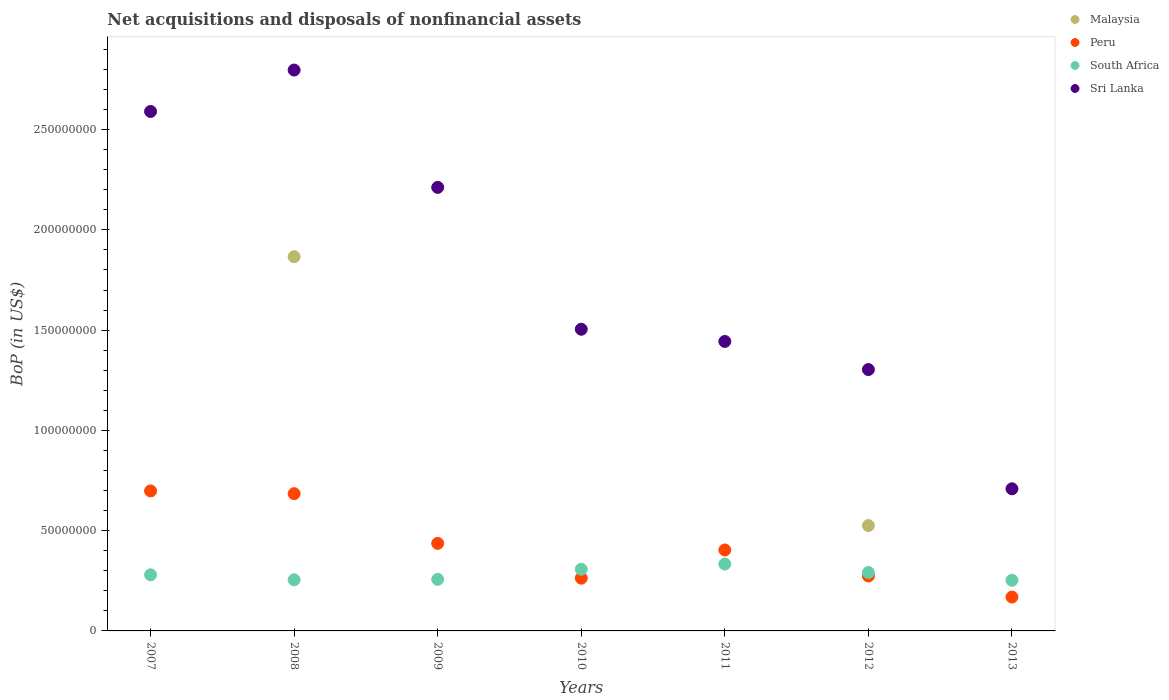How many different coloured dotlines are there?
Your response must be concise. 4. What is the Balance of Payments in South Africa in 2013?
Ensure brevity in your answer.  2.52e+07. Across all years, what is the maximum Balance of Payments in South Africa?
Your response must be concise. 3.33e+07. Across all years, what is the minimum Balance of Payments in South Africa?
Provide a short and direct response. 2.52e+07. What is the total Balance of Payments in Peru in the graph?
Give a very brief answer. 2.93e+08. What is the difference between the Balance of Payments in South Africa in 2009 and that in 2011?
Your response must be concise. -7.60e+06. What is the difference between the Balance of Payments in Malaysia in 2013 and the Balance of Payments in Peru in 2012?
Your response must be concise. -2.74e+07. What is the average Balance of Payments in Peru per year?
Offer a terse response. 4.18e+07. In the year 2013, what is the difference between the Balance of Payments in South Africa and Balance of Payments in Sri Lanka?
Make the answer very short. -4.56e+07. In how many years, is the Balance of Payments in South Africa greater than 170000000 US$?
Ensure brevity in your answer.  0. What is the ratio of the Balance of Payments in Peru in 2011 to that in 2013?
Give a very brief answer. 2.39. Is the difference between the Balance of Payments in South Africa in 2008 and 2013 greater than the difference between the Balance of Payments in Sri Lanka in 2008 and 2013?
Offer a very short reply. No. What is the difference between the highest and the second highest Balance of Payments in Peru?
Your answer should be compact. 1.36e+06. What is the difference between the highest and the lowest Balance of Payments in Sri Lanka?
Provide a short and direct response. 2.09e+08. Is the sum of the Balance of Payments in South Africa in 2010 and 2012 greater than the maximum Balance of Payments in Peru across all years?
Offer a very short reply. No. Is it the case that in every year, the sum of the Balance of Payments in South Africa and Balance of Payments in Peru  is greater than the sum of Balance of Payments in Malaysia and Balance of Payments in Sri Lanka?
Give a very brief answer. No. Is it the case that in every year, the sum of the Balance of Payments in South Africa and Balance of Payments in Sri Lanka  is greater than the Balance of Payments in Malaysia?
Your answer should be compact. Yes. Does the Balance of Payments in Malaysia monotonically increase over the years?
Ensure brevity in your answer.  No. Is the Balance of Payments in Peru strictly greater than the Balance of Payments in Sri Lanka over the years?
Provide a short and direct response. No. How many dotlines are there?
Provide a short and direct response. 4. What is the difference between two consecutive major ticks on the Y-axis?
Offer a very short reply. 5.00e+07. Are the values on the major ticks of Y-axis written in scientific E-notation?
Ensure brevity in your answer.  No. Does the graph contain any zero values?
Your response must be concise. Yes. How many legend labels are there?
Your response must be concise. 4. How are the legend labels stacked?
Your answer should be very brief. Vertical. What is the title of the graph?
Give a very brief answer. Net acquisitions and disposals of nonfinancial assets. Does "Caribbean small states" appear as one of the legend labels in the graph?
Ensure brevity in your answer.  No. What is the label or title of the Y-axis?
Your response must be concise. BoP (in US$). What is the BoP (in US$) of Peru in 2007?
Ensure brevity in your answer.  6.98e+07. What is the BoP (in US$) in South Africa in 2007?
Keep it short and to the point. 2.80e+07. What is the BoP (in US$) in Sri Lanka in 2007?
Provide a short and direct response. 2.59e+08. What is the BoP (in US$) in Malaysia in 2008?
Give a very brief answer. 1.87e+08. What is the BoP (in US$) in Peru in 2008?
Offer a very short reply. 6.84e+07. What is the BoP (in US$) of South Africa in 2008?
Offer a very short reply. 2.55e+07. What is the BoP (in US$) in Sri Lanka in 2008?
Your answer should be compact. 2.80e+08. What is the BoP (in US$) in Peru in 2009?
Your answer should be very brief. 4.37e+07. What is the BoP (in US$) of South Africa in 2009?
Offer a terse response. 2.57e+07. What is the BoP (in US$) of Sri Lanka in 2009?
Keep it short and to the point. 2.21e+08. What is the BoP (in US$) of Peru in 2010?
Provide a succinct answer. 2.63e+07. What is the BoP (in US$) of South Africa in 2010?
Ensure brevity in your answer.  3.08e+07. What is the BoP (in US$) in Sri Lanka in 2010?
Provide a succinct answer. 1.50e+08. What is the BoP (in US$) in Malaysia in 2011?
Your answer should be compact. 0. What is the BoP (in US$) in Peru in 2011?
Offer a terse response. 4.04e+07. What is the BoP (in US$) in South Africa in 2011?
Make the answer very short. 3.33e+07. What is the BoP (in US$) of Sri Lanka in 2011?
Ensure brevity in your answer.  1.44e+08. What is the BoP (in US$) in Malaysia in 2012?
Give a very brief answer. 5.25e+07. What is the BoP (in US$) of Peru in 2012?
Provide a short and direct response. 2.74e+07. What is the BoP (in US$) of South Africa in 2012?
Ensure brevity in your answer.  2.91e+07. What is the BoP (in US$) of Sri Lanka in 2012?
Offer a very short reply. 1.30e+08. What is the BoP (in US$) in Malaysia in 2013?
Provide a short and direct response. 0. What is the BoP (in US$) of Peru in 2013?
Keep it short and to the point. 1.69e+07. What is the BoP (in US$) in South Africa in 2013?
Your answer should be compact. 2.52e+07. What is the BoP (in US$) of Sri Lanka in 2013?
Make the answer very short. 7.09e+07. Across all years, what is the maximum BoP (in US$) in Malaysia?
Give a very brief answer. 1.87e+08. Across all years, what is the maximum BoP (in US$) of Peru?
Provide a succinct answer. 6.98e+07. Across all years, what is the maximum BoP (in US$) in South Africa?
Your answer should be very brief. 3.33e+07. Across all years, what is the maximum BoP (in US$) of Sri Lanka?
Give a very brief answer. 2.80e+08. Across all years, what is the minimum BoP (in US$) of Peru?
Ensure brevity in your answer.  1.69e+07. Across all years, what is the minimum BoP (in US$) of South Africa?
Keep it short and to the point. 2.52e+07. Across all years, what is the minimum BoP (in US$) in Sri Lanka?
Offer a very short reply. 7.09e+07. What is the total BoP (in US$) of Malaysia in the graph?
Offer a terse response. 2.39e+08. What is the total BoP (in US$) of Peru in the graph?
Ensure brevity in your answer.  2.93e+08. What is the total BoP (in US$) in South Africa in the graph?
Offer a terse response. 1.98e+08. What is the total BoP (in US$) in Sri Lanka in the graph?
Your answer should be very brief. 1.26e+09. What is the difference between the BoP (in US$) of Peru in 2007 and that in 2008?
Provide a succinct answer. 1.36e+06. What is the difference between the BoP (in US$) of South Africa in 2007 and that in 2008?
Make the answer very short. 2.48e+06. What is the difference between the BoP (in US$) of Sri Lanka in 2007 and that in 2008?
Provide a succinct answer. -2.06e+07. What is the difference between the BoP (in US$) of Peru in 2007 and that in 2009?
Provide a succinct answer. 2.61e+07. What is the difference between the BoP (in US$) in South Africa in 2007 and that in 2009?
Keep it short and to the point. 2.25e+06. What is the difference between the BoP (in US$) in Sri Lanka in 2007 and that in 2009?
Offer a terse response. 3.78e+07. What is the difference between the BoP (in US$) in Peru in 2007 and that in 2010?
Offer a very short reply. 4.35e+07. What is the difference between the BoP (in US$) of South Africa in 2007 and that in 2010?
Provide a short and direct response. -2.79e+06. What is the difference between the BoP (in US$) in Sri Lanka in 2007 and that in 2010?
Your response must be concise. 1.09e+08. What is the difference between the BoP (in US$) of Peru in 2007 and that in 2011?
Make the answer very short. 2.94e+07. What is the difference between the BoP (in US$) of South Africa in 2007 and that in 2011?
Provide a short and direct response. -5.35e+06. What is the difference between the BoP (in US$) of Sri Lanka in 2007 and that in 2011?
Provide a succinct answer. 1.15e+08. What is the difference between the BoP (in US$) in Peru in 2007 and that in 2012?
Give a very brief answer. 4.24e+07. What is the difference between the BoP (in US$) of South Africa in 2007 and that in 2012?
Your answer should be compact. -1.16e+06. What is the difference between the BoP (in US$) in Sri Lanka in 2007 and that in 2012?
Your answer should be compact. 1.29e+08. What is the difference between the BoP (in US$) in Peru in 2007 and that in 2013?
Give a very brief answer. 5.29e+07. What is the difference between the BoP (in US$) in South Africa in 2007 and that in 2013?
Ensure brevity in your answer.  2.74e+06. What is the difference between the BoP (in US$) in Sri Lanka in 2007 and that in 2013?
Provide a succinct answer. 1.88e+08. What is the difference between the BoP (in US$) in Peru in 2008 and that in 2009?
Ensure brevity in your answer.  2.48e+07. What is the difference between the BoP (in US$) in South Africa in 2008 and that in 2009?
Provide a short and direct response. -2.34e+05. What is the difference between the BoP (in US$) of Sri Lanka in 2008 and that in 2009?
Ensure brevity in your answer.  5.85e+07. What is the difference between the BoP (in US$) in Peru in 2008 and that in 2010?
Provide a succinct answer. 4.21e+07. What is the difference between the BoP (in US$) of South Africa in 2008 and that in 2010?
Offer a very short reply. -5.27e+06. What is the difference between the BoP (in US$) of Sri Lanka in 2008 and that in 2010?
Make the answer very short. 1.29e+08. What is the difference between the BoP (in US$) in Peru in 2008 and that in 2011?
Your answer should be very brief. 2.81e+07. What is the difference between the BoP (in US$) of South Africa in 2008 and that in 2011?
Your response must be concise. -7.83e+06. What is the difference between the BoP (in US$) in Sri Lanka in 2008 and that in 2011?
Keep it short and to the point. 1.35e+08. What is the difference between the BoP (in US$) of Malaysia in 2008 and that in 2012?
Make the answer very short. 1.34e+08. What is the difference between the BoP (in US$) in Peru in 2008 and that in 2012?
Make the answer very short. 4.10e+07. What is the difference between the BoP (in US$) of South Africa in 2008 and that in 2012?
Make the answer very short. -3.64e+06. What is the difference between the BoP (in US$) of Sri Lanka in 2008 and that in 2012?
Your answer should be very brief. 1.49e+08. What is the difference between the BoP (in US$) in Peru in 2008 and that in 2013?
Offer a terse response. 5.16e+07. What is the difference between the BoP (in US$) of South Africa in 2008 and that in 2013?
Provide a succinct answer. 2.55e+05. What is the difference between the BoP (in US$) in Sri Lanka in 2008 and that in 2013?
Make the answer very short. 2.09e+08. What is the difference between the BoP (in US$) of Peru in 2009 and that in 2010?
Your response must be concise. 1.74e+07. What is the difference between the BoP (in US$) in South Africa in 2009 and that in 2010?
Offer a terse response. -5.04e+06. What is the difference between the BoP (in US$) of Sri Lanka in 2009 and that in 2010?
Offer a very short reply. 7.08e+07. What is the difference between the BoP (in US$) of Peru in 2009 and that in 2011?
Your response must be concise. 3.30e+06. What is the difference between the BoP (in US$) in South Africa in 2009 and that in 2011?
Your answer should be compact. -7.60e+06. What is the difference between the BoP (in US$) of Sri Lanka in 2009 and that in 2011?
Your answer should be very brief. 7.68e+07. What is the difference between the BoP (in US$) in Peru in 2009 and that in 2012?
Give a very brief answer. 1.63e+07. What is the difference between the BoP (in US$) in South Africa in 2009 and that in 2012?
Ensure brevity in your answer.  -3.41e+06. What is the difference between the BoP (in US$) in Sri Lanka in 2009 and that in 2012?
Give a very brief answer. 9.09e+07. What is the difference between the BoP (in US$) of Peru in 2009 and that in 2013?
Your answer should be compact. 2.68e+07. What is the difference between the BoP (in US$) of South Africa in 2009 and that in 2013?
Make the answer very short. 4.89e+05. What is the difference between the BoP (in US$) of Sri Lanka in 2009 and that in 2013?
Provide a short and direct response. 1.50e+08. What is the difference between the BoP (in US$) in Peru in 2010 and that in 2011?
Give a very brief answer. -1.41e+07. What is the difference between the BoP (in US$) of South Africa in 2010 and that in 2011?
Ensure brevity in your answer.  -2.56e+06. What is the difference between the BoP (in US$) in Sri Lanka in 2010 and that in 2011?
Your answer should be compact. 6.09e+06. What is the difference between the BoP (in US$) of Peru in 2010 and that in 2012?
Provide a short and direct response. -1.09e+06. What is the difference between the BoP (in US$) of South Africa in 2010 and that in 2012?
Ensure brevity in your answer.  1.63e+06. What is the difference between the BoP (in US$) of Sri Lanka in 2010 and that in 2012?
Offer a very short reply. 2.01e+07. What is the difference between the BoP (in US$) in Peru in 2010 and that in 2013?
Offer a very short reply. 9.42e+06. What is the difference between the BoP (in US$) in South Africa in 2010 and that in 2013?
Your answer should be compact. 5.52e+06. What is the difference between the BoP (in US$) of Sri Lanka in 2010 and that in 2013?
Give a very brief answer. 7.96e+07. What is the difference between the BoP (in US$) in Peru in 2011 and that in 2012?
Your answer should be compact. 1.30e+07. What is the difference between the BoP (in US$) of South Africa in 2011 and that in 2012?
Make the answer very short. 4.19e+06. What is the difference between the BoP (in US$) of Sri Lanka in 2011 and that in 2012?
Your response must be concise. 1.40e+07. What is the difference between the BoP (in US$) of Peru in 2011 and that in 2013?
Offer a very short reply. 2.35e+07. What is the difference between the BoP (in US$) of South Africa in 2011 and that in 2013?
Your answer should be very brief. 8.09e+06. What is the difference between the BoP (in US$) of Sri Lanka in 2011 and that in 2013?
Provide a short and direct response. 7.35e+07. What is the difference between the BoP (in US$) of Peru in 2012 and that in 2013?
Offer a terse response. 1.05e+07. What is the difference between the BoP (in US$) of South Africa in 2012 and that in 2013?
Provide a succinct answer. 3.90e+06. What is the difference between the BoP (in US$) in Sri Lanka in 2012 and that in 2013?
Your response must be concise. 5.95e+07. What is the difference between the BoP (in US$) in Peru in 2007 and the BoP (in US$) in South Africa in 2008?
Keep it short and to the point. 4.43e+07. What is the difference between the BoP (in US$) in Peru in 2007 and the BoP (in US$) in Sri Lanka in 2008?
Your answer should be compact. -2.10e+08. What is the difference between the BoP (in US$) of South Africa in 2007 and the BoP (in US$) of Sri Lanka in 2008?
Provide a succinct answer. -2.52e+08. What is the difference between the BoP (in US$) in Peru in 2007 and the BoP (in US$) in South Africa in 2009?
Offer a very short reply. 4.41e+07. What is the difference between the BoP (in US$) of Peru in 2007 and the BoP (in US$) of Sri Lanka in 2009?
Make the answer very short. -1.51e+08. What is the difference between the BoP (in US$) of South Africa in 2007 and the BoP (in US$) of Sri Lanka in 2009?
Your answer should be compact. -1.93e+08. What is the difference between the BoP (in US$) of Peru in 2007 and the BoP (in US$) of South Africa in 2010?
Give a very brief answer. 3.90e+07. What is the difference between the BoP (in US$) in Peru in 2007 and the BoP (in US$) in Sri Lanka in 2010?
Offer a terse response. -8.06e+07. What is the difference between the BoP (in US$) in South Africa in 2007 and the BoP (in US$) in Sri Lanka in 2010?
Ensure brevity in your answer.  -1.22e+08. What is the difference between the BoP (in US$) of Peru in 2007 and the BoP (in US$) of South Africa in 2011?
Your response must be concise. 3.65e+07. What is the difference between the BoP (in US$) of Peru in 2007 and the BoP (in US$) of Sri Lanka in 2011?
Make the answer very short. -7.46e+07. What is the difference between the BoP (in US$) in South Africa in 2007 and the BoP (in US$) in Sri Lanka in 2011?
Make the answer very short. -1.16e+08. What is the difference between the BoP (in US$) in Peru in 2007 and the BoP (in US$) in South Africa in 2012?
Ensure brevity in your answer.  4.07e+07. What is the difference between the BoP (in US$) in Peru in 2007 and the BoP (in US$) in Sri Lanka in 2012?
Keep it short and to the point. -6.05e+07. What is the difference between the BoP (in US$) in South Africa in 2007 and the BoP (in US$) in Sri Lanka in 2012?
Ensure brevity in your answer.  -1.02e+08. What is the difference between the BoP (in US$) of Peru in 2007 and the BoP (in US$) of South Africa in 2013?
Provide a succinct answer. 4.46e+07. What is the difference between the BoP (in US$) of Peru in 2007 and the BoP (in US$) of Sri Lanka in 2013?
Offer a very short reply. -1.08e+06. What is the difference between the BoP (in US$) in South Africa in 2007 and the BoP (in US$) in Sri Lanka in 2013?
Provide a succinct answer. -4.29e+07. What is the difference between the BoP (in US$) of Malaysia in 2008 and the BoP (in US$) of Peru in 2009?
Your answer should be compact. 1.43e+08. What is the difference between the BoP (in US$) in Malaysia in 2008 and the BoP (in US$) in South Africa in 2009?
Offer a terse response. 1.61e+08. What is the difference between the BoP (in US$) of Malaysia in 2008 and the BoP (in US$) of Sri Lanka in 2009?
Your answer should be compact. -3.46e+07. What is the difference between the BoP (in US$) of Peru in 2008 and the BoP (in US$) of South Africa in 2009?
Make the answer very short. 4.27e+07. What is the difference between the BoP (in US$) of Peru in 2008 and the BoP (in US$) of Sri Lanka in 2009?
Give a very brief answer. -1.53e+08. What is the difference between the BoP (in US$) in South Africa in 2008 and the BoP (in US$) in Sri Lanka in 2009?
Give a very brief answer. -1.96e+08. What is the difference between the BoP (in US$) in Malaysia in 2008 and the BoP (in US$) in Peru in 2010?
Ensure brevity in your answer.  1.60e+08. What is the difference between the BoP (in US$) in Malaysia in 2008 and the BoP (in US$) in South Africa in 2010?
Your response must be concise. 1.56e+08. What is the difference between the BoP (in US$) in Malaysia in 2008 and the BoP (in US$) in Sri Lanka in 2010?
Give a very brief answer. 3.62e+07. What is the difference between the BoP (in US$) in Peru in 2008 and the BoP (in US$) in South Africa in 2010?
Offer a terse response. 3.77e+07. What is the difference between the BoP (in US$) of Peru in 2008 and the BoP (in US$) of Sri Lanka in 2010?
Your response must be concise. -8.20e+07. What is the difference between the BoP (in US$) of South Africa in 2008 and the BoP (in US$) of Sri Lanka in 2010?
Give a very brief answer. -1.25e+08. What is the difference between the BoP (in US$) of Malaysia in 2008 and the BoP (in US$) of Peru in 2011?
Your response must be concise. 1.46e+08. What is the difference between the BoP (in US$) in Malaysia in 2008 and the BoP (in US$) in South Africa in 2011?
Provide a succinct answer. 1.53e+08. What is the difference between the BoP (in US$) of Malaysia in 2008 and the BoP (in US$) of Sri Lanka in 2011?
Ensure brevity in your answer.  4.23e+07. What is the difference between the BoP (in US$) in Peru in 2008 and the BoP (in US$) in South Africa in 2011?
Make the answer very short. 3.51e+07. What is the difference between the BoP (in US$) in Peru in 2008 and the BoP (in US$) in Sri Lanka in 2011?
Offer a terse response. -7.59e+07. What is the difference between the BoP (in US$) of South Africa in 2008 and the BoP (in US$) of Sri Lanka in 2011?
Offer a terse response. -1.19e+08. What is the difference between the BoP (in US$) in Malaysia in 2008 and the BoP (in US$) in Peru in 2012?
Your answer should be compact. 1.59e+08. What is the difference between the BoP (in US$) of Malaysia in 2008 and the BoP (in US$) of South Africa in 2012?
Provide a succinct answer. 1.57e+08. What is the difference between the BoP (in US$) of Malaysia in 2008 and the BoP (in US$) of Sri Lanka in 2012?
Your response must be concise. 5.63e+07. What is the difference between the BoP (in US$) in Peru in 2008 and the BoP (in US$) in South Africa in 2012?
Offer a very short reply. 3.93e+07. What is the difference between the BoP (in US$) in Peru in 2008 and the BoP (in US$) in Sri Lanka in 2012?
Provide a succinct answer. -6.19e+07. What is the difference between the BoP (in US$) in South Africa in 2008 and the BoP (in US$) in Sri Lanka in 2012?
Make the answer very short. -1.05e+08. What is the difference between the BoP (in US$) of Malaysia in 2008 and the BoP (in US$) of Peru in 2013?
Your answer should be very brief. 1.70e+08. What is the difference between the BoP (in US$) in Malaysia in 2008 and the BoP (in US$) in South Africa in 2013?
Your answer should be very brief. 1.61e+08. What is the difference between the BoP (in US$) of Malaysia in 2008 and the BoP (in US$) of Sri Lanka in 2013?
Make the answer very short. 1.16e+08. What is the difference between the BoP (in US$) in Peru in 2008 and the BoP (in US$) in South Africa in 2013?
Offer a terse response. 4.32e+07. What is the difference between the BoP (in US$) in Peru in 2008 and the BoP (in US$) in Sri Lanka in 2013?
Your answer should be very brief. -2.44e+06. What is the difference between the BoP (in US$) in South Africa in 2008 and the BoP (in US$) in Sri Lanka in 2013?
Ensure brevity in your answer.  -4.54e+07. What is the difference between the BoP (in US$) in Peru in 2009 and the BoP (in US$) in South Africa in 2010?
Your answer should be very brief. 1.29e+07. What is the difference between the BoP (in US$) in Peru in 2009 and the BoP (in US$) in Sri Lanka in 2010?
Provide a succinct answer. -1.07e+08. What is the difference between the BoP (in US$) in South Africa in 2009 and the BoP (in US$) in Sri Lanka in 2010?
Give a very brief answer. -1.25e+08. What is the difference between the BoP (in US$) in Peru in 2009 and the BoP (in US$) in South Africa in 2011?
Offer a very short reply. 1.03e+07. What is the difference between the BoP (in US$) of Peru in 2009 and the BoP (in US$) of Sri Lanka in 2011?
Make the answer very short. -1.01e+08. What is the difference between the BoP (in US$) of South Africa in 2009 and the BoP (in US$) of Sri Lanka in 2011?
Keep it short and to the point. -1.19e+08. What is the difference between the BoP (in US$) in Peru in 2009 and the BoP (in US$) in South Africa in 2012?
Provide a short and direct response. 1.45e+07. What is the difference between the BoP (in US$) in Peru in 2009 and the BoP (in US$) in Sri Lanka in 2012?
Make the answer very short. -8.67e+07. What is the difference between the BoP (in US$) in South Africa in 2009 and the BoP (in US$) in Sri Lanka in 2012?
Give a very brief answer. -1.05e+08. What is the difference between the BoP (in US$) of Peru in 2009 and the BoP (in US$) of South Africa in 2013?
Provide a succinct answer. 1.84e+07. What is the difference between the BoP (in US$) of Peru in 2009 and the BoP (in US$) of Sri Lanka in 2013?
Make the answer very short. -2.72e+07. What is the difference between the BoP (in US$) of South Africa in 2009 and the BoP (in US$) of Sri Lanka in 2013?
Your response must be concise. -4.52e+07. What is the difference between the BoP (in US$) of Peru in 2010 and the BoP (in US$) of South Africa in 2011?
Ensure brevity in your answer.  -7.02e+06. What is the difference between the BoP (in US$) in Peru in 2010 and the BoP (in US$) in Sri Lanka in 2011?
Make the answer very short. -1.18e+08. What is the difference between the BoP (in US$) of South Africa in 2010 and the BoP (in US$) of Sri Lanka in 2011?
Your answer should be very brief. -1.14e+08. What is the difference between the BoP (in US$) in Peru in 2010 and the BoP (in US$) in South Africa in 2012?
Provide a succinct answer. -2.83e+06. What is the difference between the BoP (in US$) of Peru in 2010 and the BoP (in US$) of Sri Lanka in 2012?
Give a very brief answer. -1.04e+08. What is the difference between the BoP (in US$) of South Africa in 2010 and the BoP (in US$) of Sri Lanka in 2012?
Give a very brief answer. -9.96e+07. What is the difference between the BoP (in US$) of Peru in 2010 and the BoP (in US$) of South Africa in 2013?
Provide a succinct answer. 1.07e+06. What is the difference between the BoP (in US$) in Peru in 2010 and the BoP (in US$) in Sri Lanka in 2013?
Provide a succinct answer. -4.46e+07. What is the difference between the BoP (in US$) of South Africa in 2010 and the BoP (in US$) of Sri Lanka in 2013?
Offer a terse response. -4.01e+07. What is the difference between the BoP (in US$) in Peru in 2011 and the BoP (in US$) in South Africa in 2012?
Provide a short and direct response. 1.12e+07. What is the difference between the BoP (in US$) in Peru in 2011 and the BoP (in US$) in Sri Lanka in 2012?
Offer a terse response. -9.00e+07. What is the difference between the BoP (in US$) of South Africa in 2011 and the BoP (in US$) of Sri Lanka in 2012?
Your response must be concise. -9.70e+07. What is the difference between the BoP (in US$) in Peru in 2011 and the BoP (in US$) in South Africa in 2013?
Make the answer very short. 1.51e+07. What is the difference between the BoP (in US$) of Peru in 2011 and the BoP (in US$) of Sri Lanka in 2013?
Provide a short and direct response. -3.05e+07. What is the difference between the BoP (in US$) of South Africa in 2011 and the BoP (in US$) of Sri Lanka in 2013?
Give a very brief answer. -3.76e+07. What is the difference between the BoP (in US$) of Malaysia in 2012 and the BoP (in US$) of Peru in 2013?
Give a very brief answer. 3.56e+07. What is the difference between the BoP (in US$) of Malaysia in 2012 and the BoP (in US$) of South Africa in 2013?
Provide a succinct answer. 2.73e+07. What is the difference between the BoP (in US$) in Malaysia in 2012 and the BoP (in US$) in Sri Lanka in 2013?
Make the answer very short. -1.83e+07. What is the difference between the BoP (in US$) in Peru in 2012 and the BoP (in US$) in South Africa in 2013?
Keep it short and to the point. 2.15e+06. What is the difference between the BoP (in US$) in Peru in 2012 and the BoP (in US$) in Sri Lanka in 2013?
Your answer should be very brief. -4.35e+07. What is the difference between the BoP (in US$) in South Africa in 2012 and the BoP (in US$) in Sri Lanka in 2013?
Give a very brief answer. -4.17e+07. What is the average BoP (in US$) in Malaysia per year?
Provide a succinct answer. 3.42e+07. What is the average BoP (in US$) in Peru per year?
Offer a very short reply. 4.18e+07. What is the average BoP (in US$) of South Africa per year?
Make the answer very short. 2.82e+07. What is the average BoP (in US$) of Sri Lanka per year?
Your response must be concise. 1.79e+08. In the year 2007, what is the difference between the BoP (in US$) of Peru and BoP (in US$) of South Africa?
Give a very brief answer. 4.18e+07. In the year 2007, what is the difference between the BoP (in US$) of Peru and BoP (in US$) of Sri Lanka?
Provide a short and direct response. -1.89e+08. In the year 2007, what is the difference between the BoP (in US$) of South Africa and BoP (in US$) of Sri Lanka?
Offer a very short reply. -2.31e+08. In the year 2008, what is the difference between the BoP (in US$) of Malaysia and BoP (in US$) of Peru?
Give a very brief answer. 1.18e+08. In the year 2008, what is the difference between the BoP (in US$) in Malaysia and BoP (in US$) in South Africa?
Ensure brevity in your answer.  1.61e+08. In the year 2008, what is the difference between the BoP (in US$) in Malaysia and BoP (in US$) in Sri Lanka?
Your answer should be compact. -9.31e+07. In the year 2008, what is the difference between the BoP (in US$) in Peru and BoP (in US$) in South Africa?
Your answer should be compact. 4.29e+07. In the year 2008, what is the difference between the BoP (in US$) of Peru and BoP (in US$) of Sri Lanka?
Keep it short and to the point. -2.11e+08. In the year 2008, what is the difference between the BoP (in US$) in South Africa and BoP (in US$) in Sri Lanka?
Your response must be concise. -2.54e+08. In the year 2009, what is the difference between the BoP (in US$) of Peru and BoP (in US$) of South Africa?
Keep it short and to the point. 1.79e+07. In the year 2009, what is the difference between the BoP (in US$) in Peru and BoP (in US$) in Sri Lanka?
Your answer should be compact. -1.78e+08. In the year 2009, what is the difference between the BoP (in US$) of South Africa and BoP (in US$) of Sri Lanka?
Give a very brief answer. -1.95e+08. In the year 2010, what is the difference between the BoP (in US$) in Peru and BoP (in US$) in South Africa?
Your answer should be very brief. -4.46e+06. In the year 2010, what is the difference between the BoP (in US$) of Peru and BoP (in US$) of Sri Lanka?
Provide a short and direct response. -1.24e+08. In the year 2010, what is the difference between the BoP (in US$) in South Africa and BoP (in US$) in Sri Lanka?
Keep it short and to the point. -1.20e+08. In the year 2011, what is the difference between the BoP (in US$) of Peru and BoP (in US$) of South Africa?
Give a very brief answer. 7.04e+06. In the year 2011, what is the difference between the BoP (in US$) in Peru and BoP (in US$) in Sri Lanka?
Ensure brevity in your answer.  -1.04e+08. In the year 2011, what is the difference between the BoP (in US$) of South Africa and BoP (in US$) of Sri Lanka?
Your answer should be very brief. -1.11e+08. In the year 2012, what is the difference between the BoP (in US$) in Malaysia and BoP (in US$) in Peru?
Your answer should be compact. 2.51e+07. In the year 2012, what is the difference between the BoP (in US$) in Malaysia and BoP (in US$) in South Africa?
Offer a terse response. 2.34e+07. In the year 2012, what is the difference between the BoP (in US$) of Malaysia and BoP (in US$) of Sri Lanka?
Offer a very short reply. -7.78e+07. In the year 2012, what is the difference between the BoP (in US$) in Peru and BoP (in US$) in South Africa?
Your response must be concise. -1.74e+06. In the year 2012, what is the difference between the BoP (in US$) of Peru and BoP (in US$) of Sri Lanka?
Make the answer very short. -1.03e+08. In the year 2012, what is the difference between the BoP (in US$) of South Africa and BoP (in US$) of Sri Lanka?
Offer a very short reply. -1.01e+08. In the year 2013, what is the difference between the BoP (in US$) in Peru and BoP (in US$) in South Africa?
Provide a succinct answer. -8.35e+06. In the year 2013, what is the difference between the BoP (in US$) in Peru and BoP (in US$) in Sri Lanka?
Your answer should be compact. -5.40e+07. In the year 2013, what is the difference between the BoP (in US$) of South Africa and BoP (in US$) of Sri Lanka?
Your answer should be very brief. -4.56e+07. What is the ratio of the BoP (in US$) in Peru in 2007 to that in 2008?
Keep it short and to the point. 1.02. What is the ratio of the BoP (in US$) in South Africa in 2007 to that in 2008?
Your answer should be very brief. 1.1. What is the ratio of the BoP (in US$) of Sri Lanka in 2007 to that in 2008?
Offer a very short reply. 0.93. What is the ratio of the BoP (in US$) of Peru in 2007 to that in 2009?
Offer a very short reply. 1.6. What is the ratio of the BoP (in US$) in South Africa in 2007 to that in 2009?
Keep it short and to the point. 1.09. What is the ratio of the BoP (in US$) in Sri Lanka in 2007 to that in 2009?
Give a very brief answer. 1.17. What is the ratio of the BoP (in US$) of Peru in 2007 to that in 2010?
Your answer should be very brief. 2.65. What is the ratio of the BoP (in US$) of South Africa in 2007 to that in 2010?
Provide a short and direct response. 0.91. What is the ratio of the BoP (in US$) in Sri Lanka in 2007 to that in 2010?
Offer a terse response. 1.72. What is the ratio of the BoP (in US$) in Peru in 2007 to that in 2011?
Give a very brief answer. 1.73. What is the ratio of the BoP (in US$) in South Africa in 2007 to that in 2011?
Your answer should be very brief. 0.84. What is the ratio of the BoP (in US$) in Sri Lanka in 2007 to that in 2011?
Make the answer very short. 1.79. What is the ratio of the BoP (in US$) of Peru in 2007 to that in 2012?
Ensure brevity in your answer.  2.55. What is the ratio of the BoP (in US$) of South Africa in 2007 to that in 2012?
Make the answer very short. 0.96. What is the ratio of the BoP (in US$) in Sri Lanka in 2007 to that in 2012?
Ensure brevity in your answer.  1.99. What is the ratio of the BoP (in US$) in Peru in 2007 to that in 2013?
Offer a very short reply. 4.13. What is the ratio of the BoP (in US$) of South Africa in 2007 to that in 2013?
Give a very brief answer. 1.11. What is the ratio of the BoP (in US$) in Sri Lanka in 2007 to that in 2013?
Your answer should be very brief. 3.65. What is the ratio of the BoP (in US$) in Peru in 2008 to that in 2009?
Provide a succinct answer. 1.57. What is the ratio of the BoP (in US$) in South Africa in 2008 to that in 2009?
Offer a terse response. 0.99. What is the ratio of the BoP (in US$) in Sri Lanka in 2008 to that in 2009?
Keep it short and to the point. 1.26. What is the ratio of the BoP (in US$) in Peru in 2008 to that in 2010?
Offer a terse response. 2.6. What is the ratio of the BoP (in US$) in South Africa in 2008 to that in 2010?
Your answer should be very brief. 0.83. What is the ratio of the BoP (in US$) of Sri Lanka in 2008 to that in 2010?
Your answer should be very brief. 1.86. What is the ratio of the BoP (in US$) in Peru in 2008 to that in 2011?
Your answer should be compact. 1.7. What is the ratio of the BoP (in US$) of South Africa in 2008 to that in 2011?
Offer a terse response. 0.77. What is the ratio of the BoP (in US$) of Sri Lanka in 2008 to that in 2011?
Offer a very short reply. 1.94. What is the ratio of the BoP (in US$) of Malaysia in 2008 to that in 2012?
Your answer should be very brief. 3.55. What is the ratio of the BoP (in US$) of Peru in 2008 to that in 2012?
Offer a terse response. 2.5. What is the ratio of the BoP (in US$) in South Africa in 2008 to that in 2012?
Your response must be concise. 0.87. What is the ratio of the BoP (in US$) of Sri Lanka in 2008 to that in 2012?
Offer a terse response. 2.15. What is the ratio of the BoP (in US$) of Peru in 2008 to that in 2013?
Provide a succinct answer. 4.05. What is the ratio of the BoP (in US$) in South Africa in 2008 to that in 2013?
Provide a succinct answer. 1.01. What is the ratio of the BoP (in US$) of Sri Lanka in 2008 to that in 2013?
Ensure brevity in your answer.  3.95. What is the ratio of the BoP (in US$) in Peru in 2009 to that in 2010?
Keep it short and to the point. 1.66. What is the ratio of the BoP (in US$) of South Africa in 2009 to that in 2010?
Provide a short and direct response. 0.84. What is the ratio of the BoP (in US$) of Sri Lanka in 2009 to that in 2010?
Offer a terse response. 1.47. What is the ratio of the BoP (in US$) in Peru in 2009 to that in 2011?
Provide a succinct answer. 1.08. What is the ratio of the BoP (in US$) in South Africa in 2009 to that in 2011?
Your answer should be compact. 0.77. What is the ratio of the BoP (in US$) in Sri Lanka in 2009 to that in 2011?
Ensure brevity in your answer.  1.53. What is the ratio of the BoP (in US$) of Peru in 2009 to that in 2012?
Ensure brevity in your answer.  1.59. What is the ratio of the BoP (in US$) in South Africa in 2009 to that in 2012?
Offer a terse response. 0.88. What is the ratio of the BoP (in US$) of Sri Lanka in 2009 to that in 2012?
Make the answer very short. 1.7. What is the ratio of the BoP (in US$) of Peru in 2009 to that in 2013?
Provide a succinct answer. 2.59. What is the ratio of the BoP (in US$) in South Africa in 2009 to that in 2013?
Give a very brief answer. 1.02. What is the ratio of the BoP (in US$) of Sri Lanka in 2009 to that in 2013?
Your answer should be compact. 3.12. What is the ratio of the BoP (in US$) of Peru in 2010 to that in 2011?
Make the answer very short. 0.65. What is the ratio of the BoP (in US$) of Sri Lanka in 2010 to that in 2011?
Keep it short and to the point. 1.04. What is the ratio of the BoP (in US$) of Peru in 2010 to that in 2012?
Ensure brevity in your answer.  0.96. What is the ratio of the BoP (in US$) in South Africa in 2010 to that in 2012?
Provide a short and direct response. 1.06. What is the ratio of the BoP (in US$) of Sri Lanka in 2010 to that in 2012?
Give a very brief answer. 1.15. What is the ratio of the BoP (in US$) of Peru in 2010 to that in 2013?
Give a very brief answer. 1.56. What is the ratio of the BoP (in US$) in South Africa in 2010 to that in 2013?
Offer a very short reply. 1.22. What is the ratio of the BoP (in US$) of Sri Lanka in 2010 to that in 2013?
Give a very brief answer. 2.12. What is the ratio of the BoP (in US$) in Peru in 2011 to that in 2012?
Your answer should be compact. 1.47. What is the ratio of the BoP (in US$) of South Africa in 2011 to that in 2012?
Your answer should be very brief. 1.14. What is the ratio of the BoP (in US$) in Sri Lanka in 2011 to that in 2012?
Provide a short and direct response. 1.11. What is the ratio of the BoP (in US$) in Peru in 2011 to that in 2013?
Provide a short and direct response. 2.39. What is the ratio of the BoP (in US$) in South Africa in 2011 to that in 2013?
Your answer should be compact. 1.32. What is the ratio of the BoP (in US$) in Sri Lanka in 2011 to that in 2013?
Make the answer very short. 2.04. What is the ratio of the BoP (in US$) in Peru in 2012 to that in 2013?
Provide a succinct answer. 1.62. What is the ratio of the BoP (in US$) in South Africa in 2012 to that in 2013?
Your response must be concise. 1.15. What is the ratio of the BoP (in US$) in Sri Lanka in 2012 to that in 2013?
Offer a very short reply. 1.84. What is the difference between the highest and the second highest BoP (in US$) of Peru?
Provide a short and direct response. 1.36e+06. What is the difference between the highest and the second highest BoP (in US$) of South Africa?
Your answer should be compact. 2.56e+06. What is the difference between the highest and the second highest BoP (in US$) in Sri Lanka?
Give a very brief answer. 2.06e+07. What is the difference between the highest and the lowest BoP (in US$) of Malaysia?
Make the answer very short. 1.87e+08. What is the difference between the highest and the lowest BoP (in US$) in Peru?
Make the answer very short. 5.29e+07. What is the difference between the highest and the lowest BoP (in US$) of South Africa?
Offer a very short reply. 8.09e+06. What is the difference between the highest and the lowest BoP (in US$) of Sri Lanka?
Give a very brief answer. 2.09e+08. 